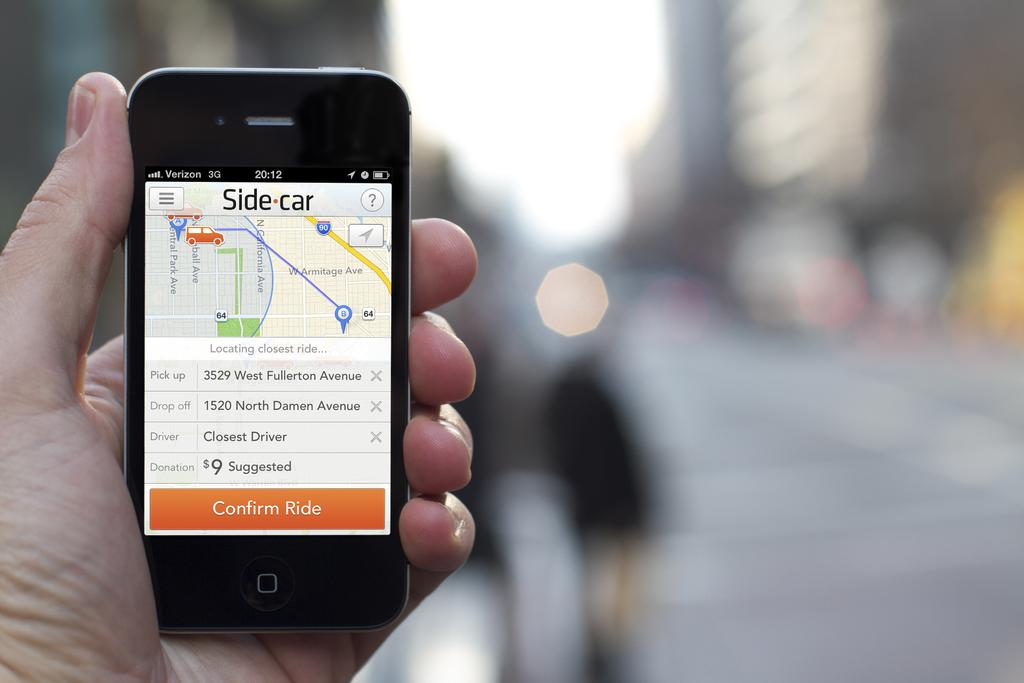<image>
Describe the image concisely. A hand holding a mobile phone with the Side Car app pulled up. 